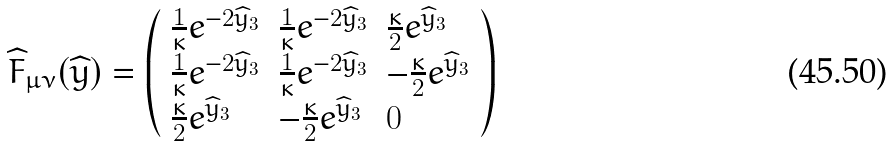Convert formula to latex. <formula><loc_0><loc_0><loc_500><loc_500>\widehat { F } _ { \mu \nu } ( \widehat { y } ) = \left ( \begin{array} { l l l } \frac { 1 } { \kappa } e ^ { - 2 \widehat { y } _ { 3 } } & \frac { 1 } { \kappa } e ^ { - 2 \widehat { y } _ { 3 } } & \frac { \kappa } { 2 } e ^ { \widehat { y } _ { 3 } } \\ \frac { 1 } { \kappa } e ^ { - 2 \widehat { y } _ { 3 } } & \frac { 1 } { \kappa } e ^ { - 2 \widehat { y } _ { 3 } } & - \frac { \kappa } { 2 } e ^ { \widehat { y } _ { 3 } } \\ \frac { \kappa } { 2 } e ^ { \widehat { y } _ { 3 } } & - \frac { \kappa } { 2 } e ^ { \widehat { y } _ { 3 } } & 0 \\ \end{array} \right )</formula> 